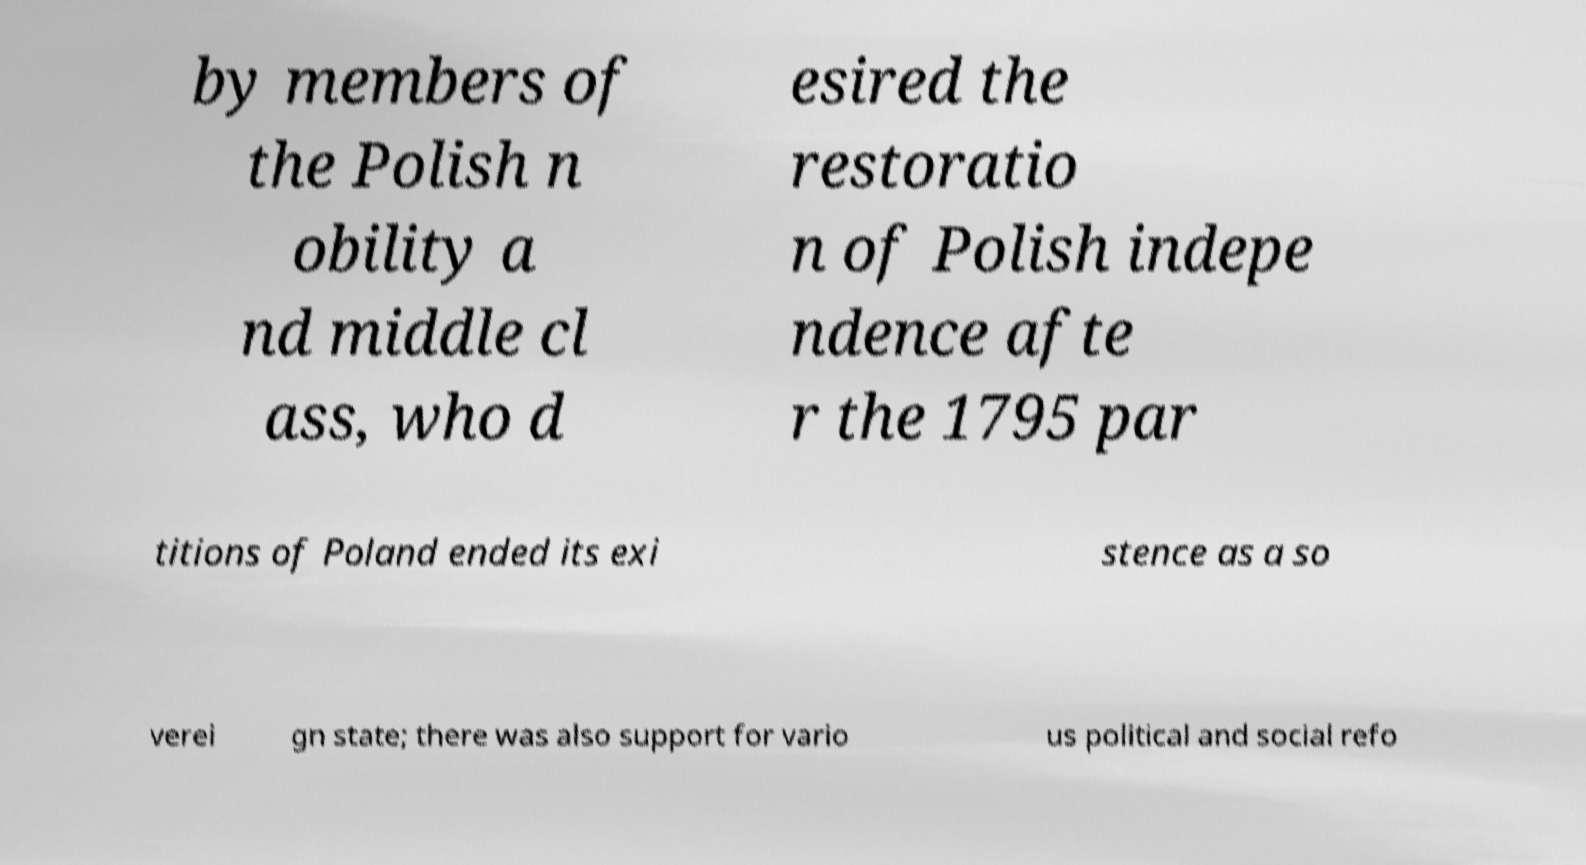I need the written content from this picture converted into text. Can you do that? by members of the Polish n obility a nd middle cl ass, who d esired the restoratio n of Polish indepe ndence afte r the 1795 par titions of Poland ended its exi stence as a so verei gn state; there was also support for vario us political and social refo 